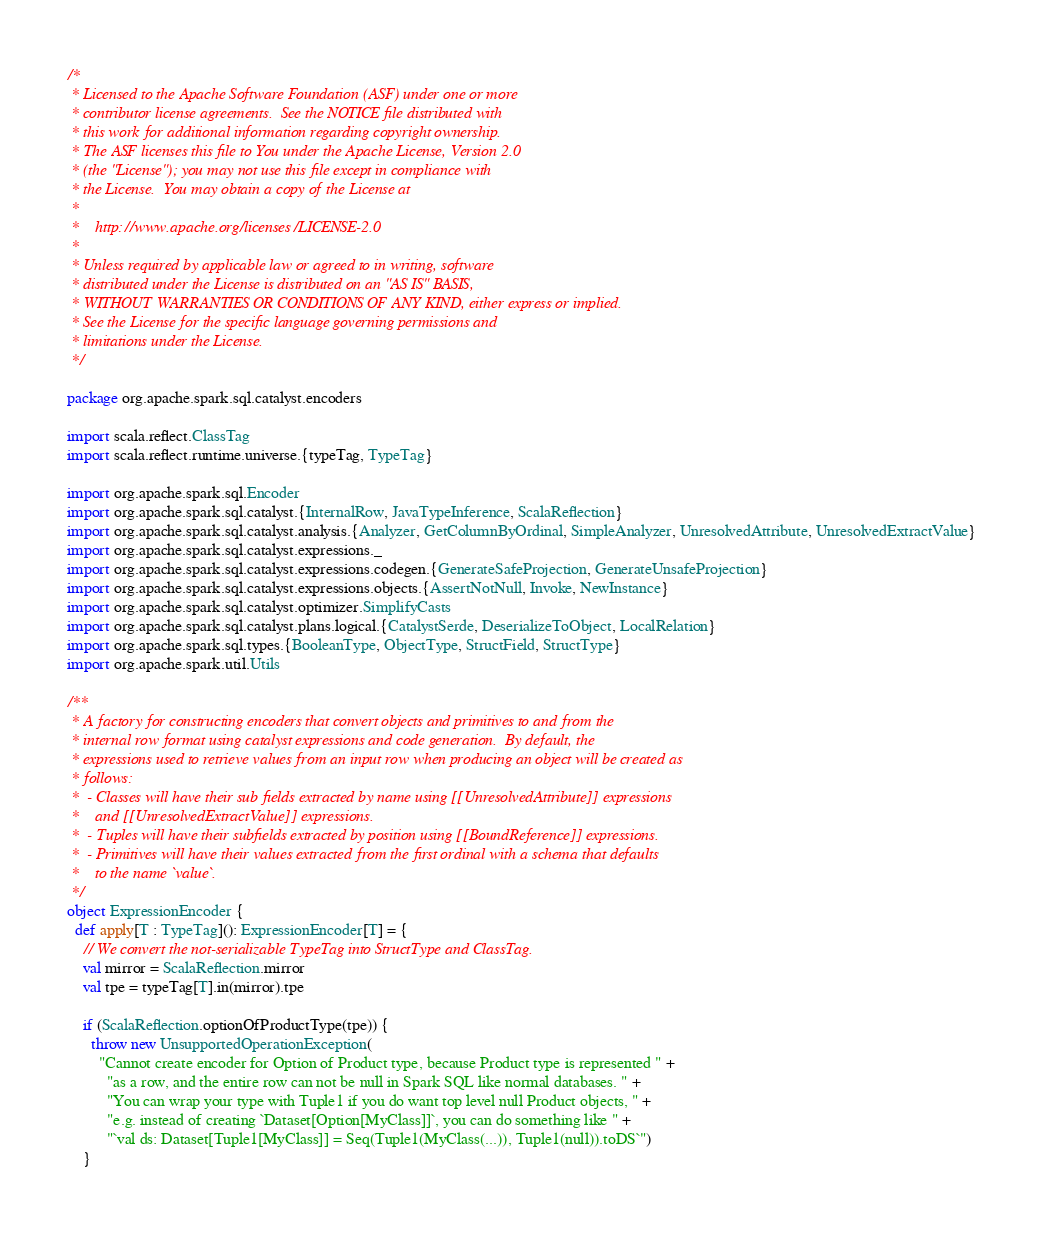<code> <loc_0><loc_0><loc_500><loc_500><_Scala_>/*
 * Licensed to the Apache Software Foundation (ASF) under one or more
 * contributor license agreements.  See the NOTICE file distributed with
 * this work for additional information regarding copyright ownership.
 * The ASF licenses this file to You under the Apache License, Version 2.0
 * (the "License"); you may not use this file except in compliance with
 * the License.  You may obtain a copy of the License at
 *
 *    http://www.apache.org/licenses/LICENSE-2.0
 *
 * Unless required by applicable law or agreed to in writing, software
 * distributed under the License is distributed on an "AS IS" BASIS,
 * WITHOUT WARRANTIES OR CONDITIONS OF ANY KIND, either express or implied.
 * See the License for the specific language governing permissions and
 * limitations under the License.
 */

package org.apache.spark.sql.catalyst.encoders

import scala.reflect.ClassTag
import scala.reflect.runtime.universe.{typeTag, TypeTag}

import org.apache.spark.sql.Encoder
import org.apache.spark.sql.catalyst.{InternalRow, JavaTypeInference, ScalaReflection}
import org.apache.spark.sql.catalyst.analysis.{Analyzer, GetColumnByOrdinal, SimpleAnalyzer, UnresolvedAttribute, UnresolvedExtractValue}
import org.apache.spark.sql.catalyst.expressions._
import org.apache.spark.sql.catalyst.expressions.codegen.{GenerateSafeProjection, GenerateUnsafeProjection}
import org.apache.spark.sql.catalyst.expressions.objects.{AssertNotNull, Invoke, NewInstance}
import org.apache.spark.sql.catalyst.optimizer.SimplifyCasts
import org.apache.spark.sql.catalyst.plans.logical.{CatalystSerde, DeserializeToObject, LocalRelation}
import org.apache.spark.sql.types.{BooleanType, ObjectType, StructField, StructType}
import org.apache.spark.util.Utils

/**
 * A factory for constructing encoders that convert objects and primitives to and from the
 * internal row format using catalyst expressions and code generation.  By default, the
 * expressions used to retrieve values from an input row when producing an object will be created as
 * follows:
 *  - Classes will have their sub fields extracted by name using [[UnresolvedAttribute]] expressions
 *    and [[UnresolvedExtractValue]] expressions.
 *  - Tuples will have their subfields extracted by position using [[BoundReference]] expressions.
 *  - Primitives will have their values extracted from the first ordinal with a schema that defaults
 *    to the name `value`.
 */
object ExpressionEncoder {
  def apply[T : TypeTag](): ExpressionEncoder[T] = {
    // We convert the not-serializable TypeTag into StructType and ClassTag.
    val mirror = ScalaReflection.mirror
    val tpe = typeTag[T].in(mirror).tpe

    if (ScalaReflection.optionOfProductType(tpe)) {
      throw new UnsupportedOperationException(
        "Cannot create encoder for Option of Product type, because Product type is represented " +
          "as a row, and the entire row can not be null in Spark SQL like normal databases. " +
          "You can wrap your type with Tuple1 if you do want top level null Product objects, " +
          "e.g. instead of creating `Dataset[Option[MyClass]]`, you can do something like " +
          "`val ds: Dataset[Tuple1[MyClass]] = Seq(Tuple1(MyClass(...)), Tuple1(null)).toDS`")
    }
</code> 